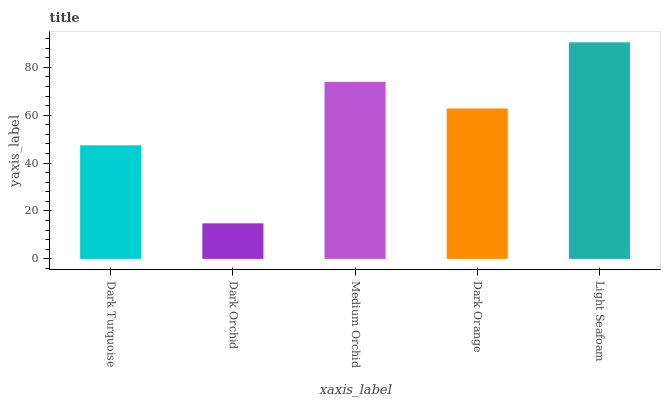Is Dark Orchid the minimum?
Answer yes or no. Yes. Is Light Seafoam the maximum?
Answer yes or no. Yes. Is Medium Orchid the minimum?
Answer yes or no. No. Is Medium Orchid the maximum?
Answer yes or no. No. Is Medium Orchid greater than Dark Orchid?
Answer yes or no. Yes. Is Dark Orchid less than Medium Orchid?
Answer yes or no. Yes. Is Dark Orchid greater than Medium Orchid?
Answer yes or no. No. Is Medium Orchid less than Dark Orchid?
Answer yes or no. No. Is Dark Orange the high median?
Answer yes or no. Yes. Is Dark Orange the low median?
Answer yes or no. Yes. Is Dark Orchid the high median?
Answer yes or no. No. Is Dark Orchid the low median?
Answer yes or no. No. 